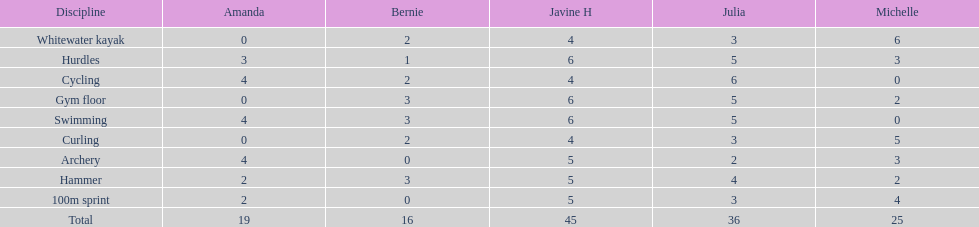State a young lady who reached equal results in cycle racing and bow and arrow competitions. Amanda. Can you give me this table as a dict? {'header': ['Discipline', 'Amanda', 'Bernie', 'Javine H', 'Julia', 'Michelle'], 'rows': [['Whitewater kayak', '0', '2', '4', '3', '6'], ['Hurdles', '3', '1', '6', '5', '3'], ['Cycling', '4', '2', '4', '6', '0'], ['Gym floor', '0', '3', '6', '5', '2'], ['Swimming', '4', '3', '6', '5', '0'], ['Curling', '0', '2', '4', '3', '5'], ['Archery', '4', '0', '5', '2', '3'], ['Hammer', '2', '3', '5', '4', '2'], ['100m sprint', '2', '0', '5', '3', '4'], ['Total', '19', '16', '45', '36', '25']]} 